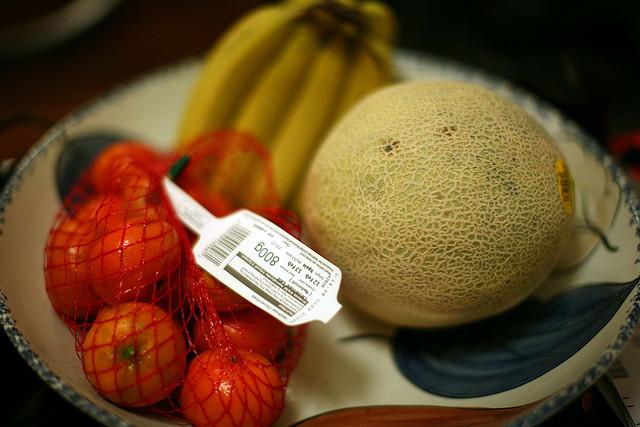What is the fruit in the bowl?
Short answer required. Banana. Is the tomato sliced?
Give a very brief answer. No. Are all three pieces of food classified as fruit?
Answer briefly. Yes. What kind of fruit is on the plate?
Be succinct. Cantaloupe. Are the colors on the plate complementary to the color of the orange?
Be succinct. Yes. Is there a vegetable?
Answer briefly. No. Is there meat on the white plate?
Give a very brief answer. No. Are one of the produce items a melon?
Be succinct. Yes. What type of fruit do you see?
Quick response, please. Cantaloupe. What is the green thing painted on the plate?
Quick response, please. Leaf. What is on the fruit?
Answer briefly. Tag. 